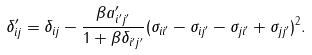<formula> <loc_0><loc_0><loc_500><loc_500>\delta _ { i j } ^ { \prime } = \delta _ { i j } - \frac { \beta a _ { i ^ { \prime } j ^ { \prime } } ^ { \prime } } { 1 + \beta \delta _ { i ^ { \prime } j ^ { \prime } } } ( \sigma _ { i i ^ { \prime } } - \sigma _ { i j ^ { \prime } } - \sigma _ { j i ^ { \prime } } + \sigma _ { j j ^ { \prime } } ) ^ { 2 } .</formula> 